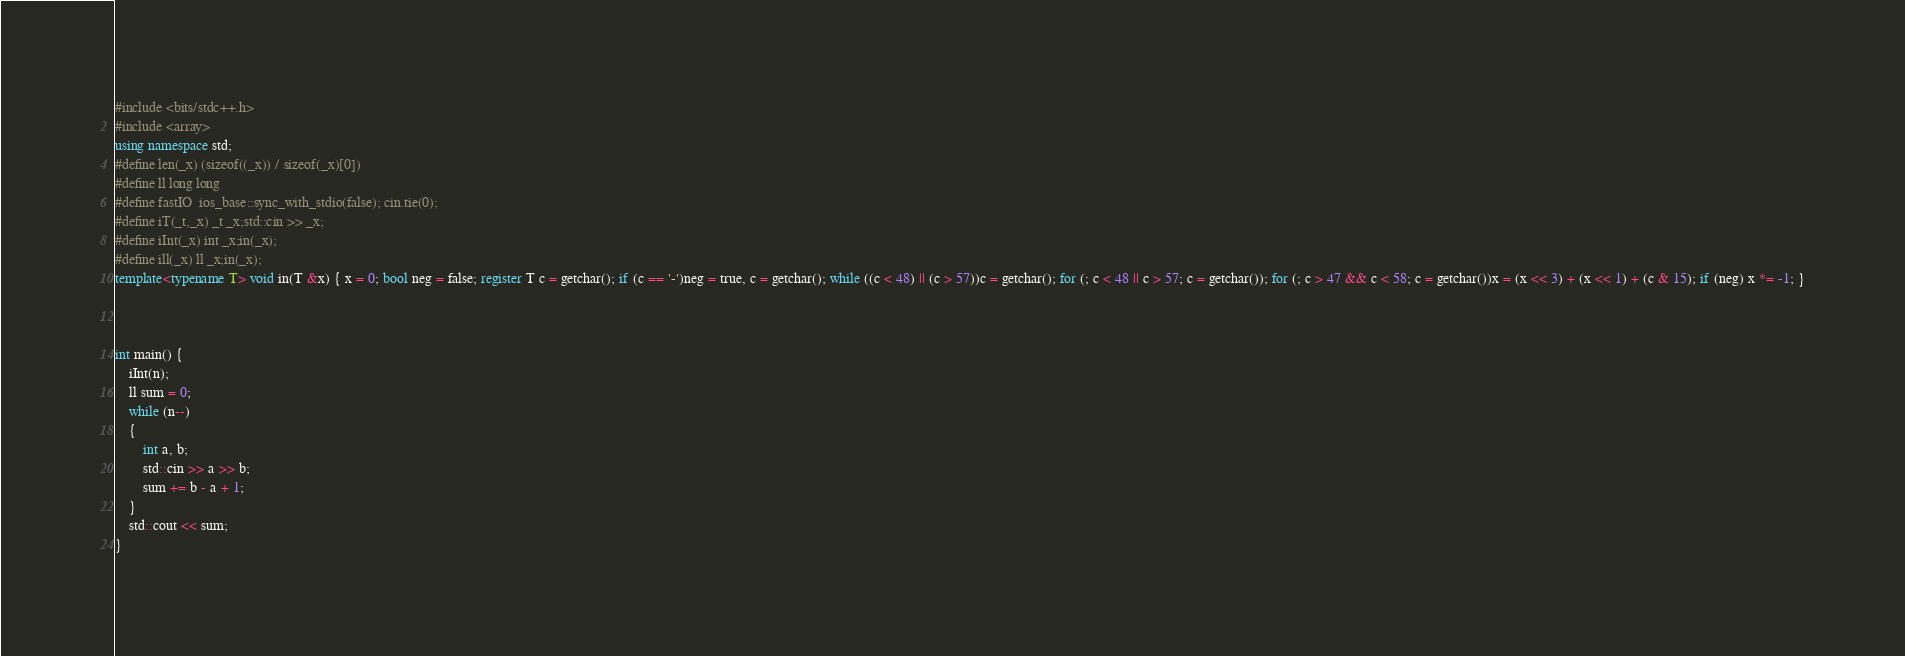<code> <loc_0><loc_0><loc_500><loc_500><_C++_>#include <bits/stdc++.h>
#include <array>
using namespace std;
#define len(_x) (sizeof((_x)) / sizeof(_x)[0])
#define ll long long
#define fastIO  ios_base::sync_with_stdio(false); cin.tie(0); 
#define iT(_t,_x) _t _x;std::cin >> _x;  
#define iInt(_x) int _x;in(_x); 
#define ill(_x) ll _x;in(_x); 
template<typename T> void in(T &x) { x = 0; bool neg = false; register T c = getchar(); if (c == '-')neg = true, c = getchar(); while ((c < 48) || (c > 57))c = getchar(); for (; c < 48 || c > 57; c = getchar()); for (; c > 47 && c < 58; c = getchar())x = (x << 3) + (x << 1) + (c & 15); if (neg) x *= -1; }



int main() {
	iInt(n);
	ll sum = 0;
	while (n--)
	{
		int a, b;
		std::cin >> a >> b;
		sum += b - a + 1;
	}
	std::cout << sum;
}
</code> 